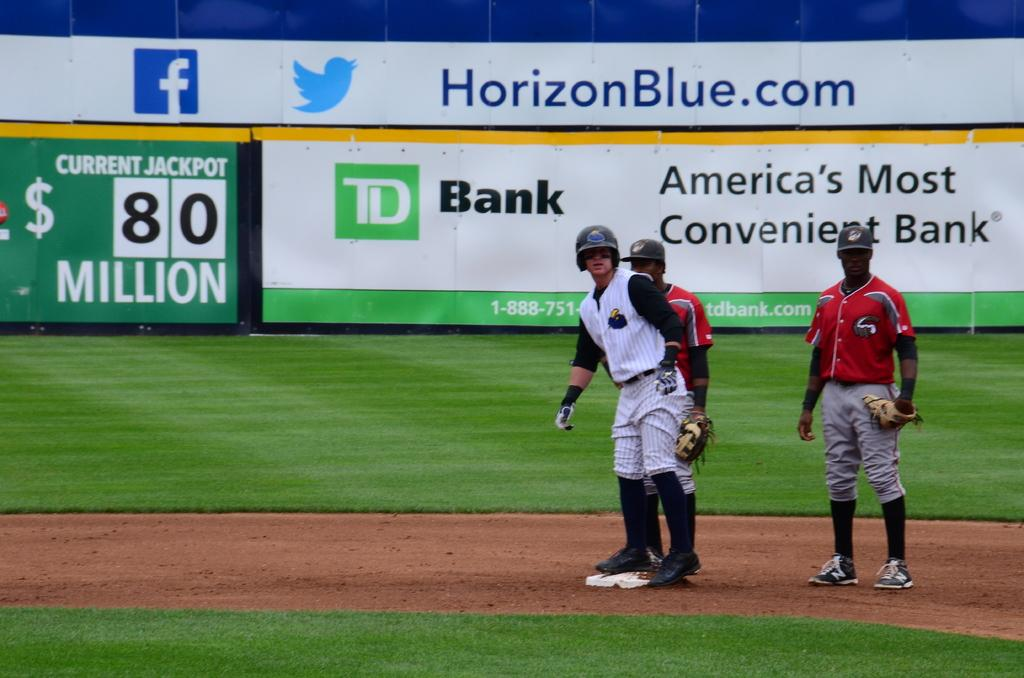Provide a one-sentence caption for the provided image. a player playing baseball with a horizonblue.com ad in the back. 